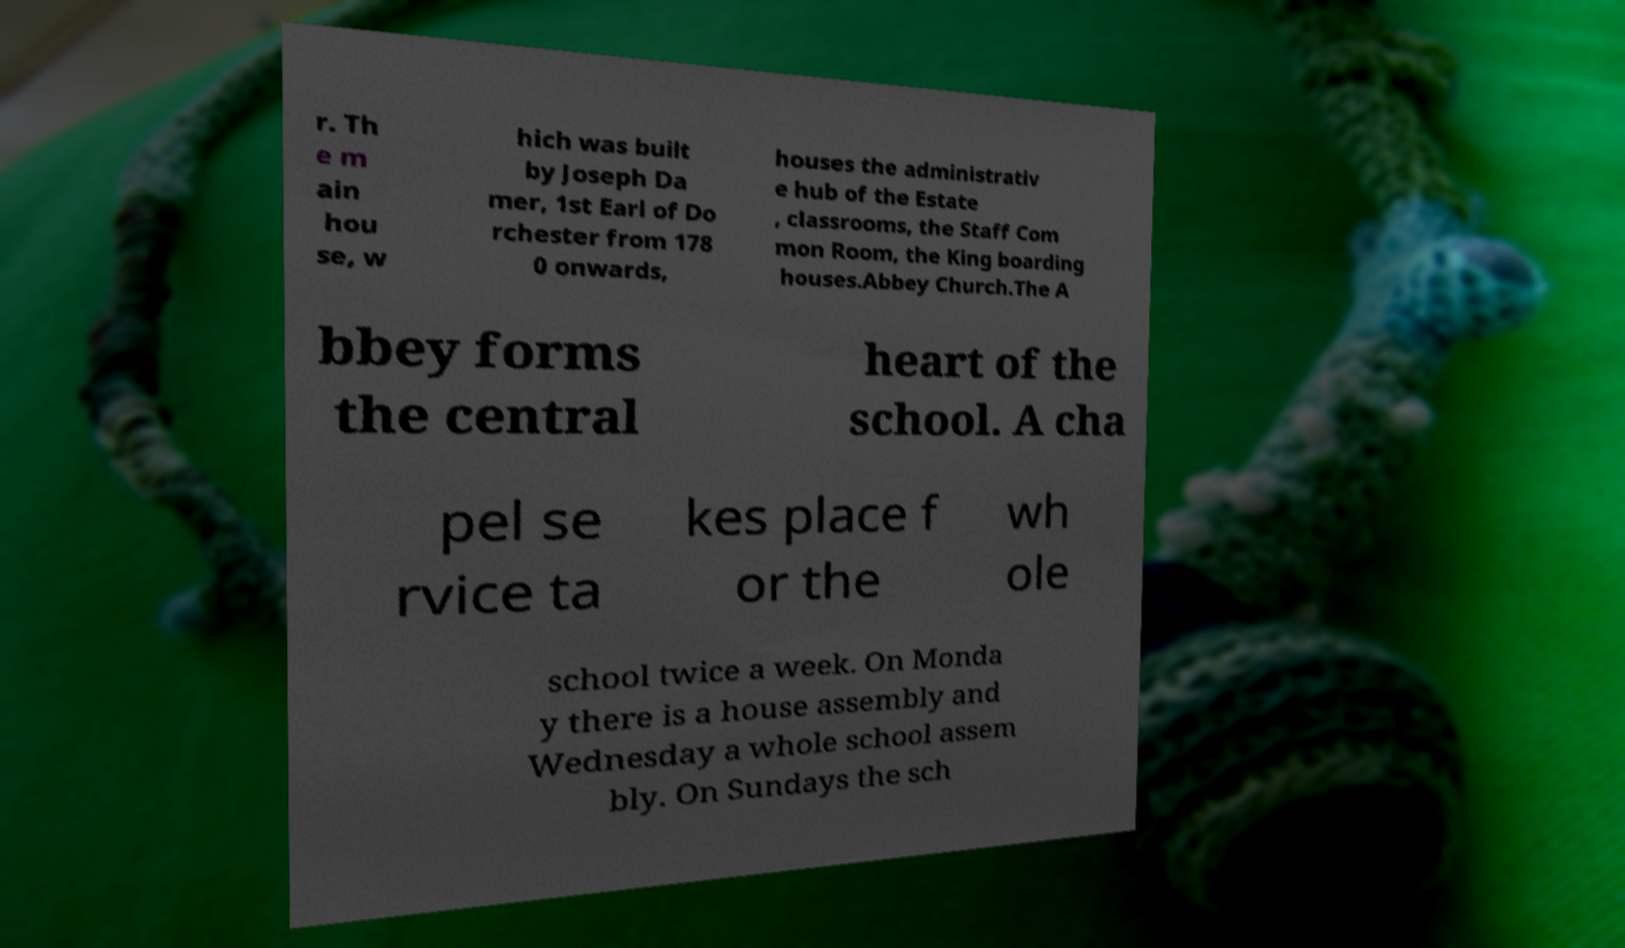Please read and relay the text visible in this image. What does it say? r. Th e m ain hou se, w hich was built by Joseph Da mer, 1st Earl of Do rchester from 178 0 onwards, houses the administrativ e hub of the Estate , classrooms, the Staff Com mon Room, the King boarding houses.Abbey Church.The A bbey forms the central heart of the school. A cha pel se rvice ta kes place f or the wh ole school twice a week. On Monda y there is a house assembly and Wednesday a whole school assem bly. On Sundays the sch 